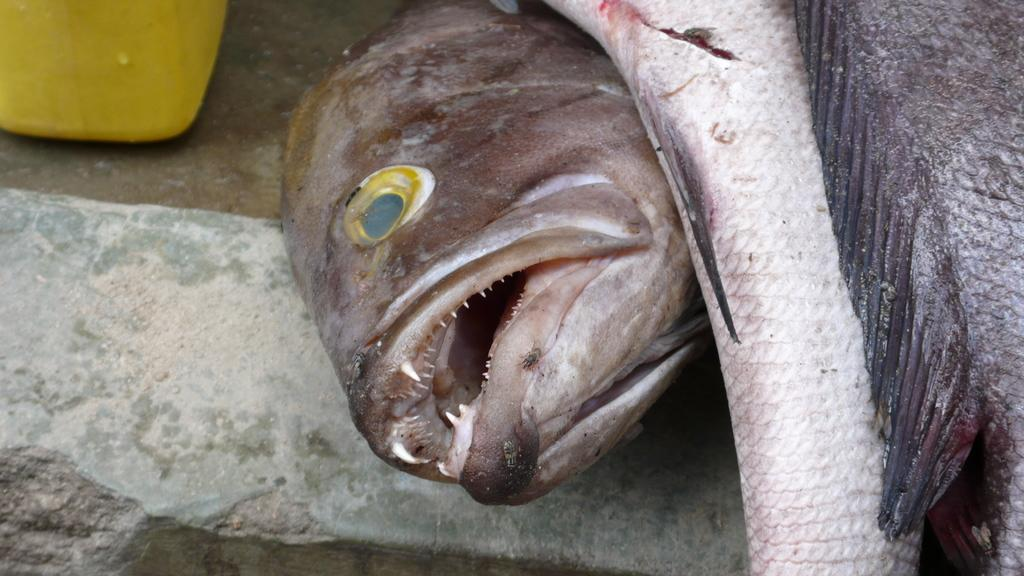What type of animals can be seen on the ground in the image? There are fishes on the ground in the image. What color is the prominent object in the image? There is a yellow object in the image. What rate of inflation is mentioned in the image? There is no mention of inflation or any rates in the image. What type of musical note can be seen in the image? There are no musical notes present in the image. 